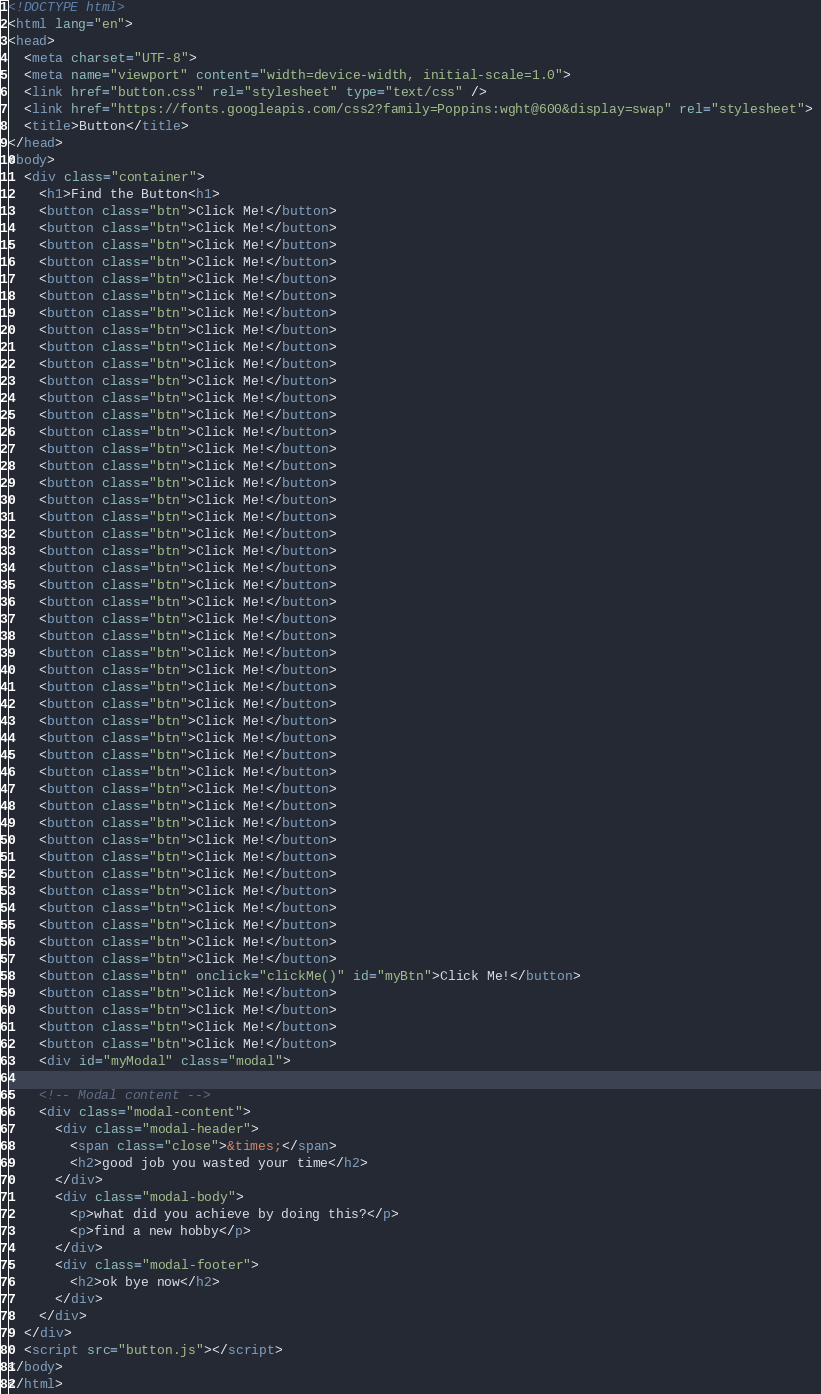Convert code to text. <code><loc_0><loc_0><loc_500><loc_500><_HTML_><!DOCTYPE html>
<html lang="en">
<head>
  <meta charset="UTF-8">
  <meta name="viewport" content="width=device-width, initial-scale=1.0">
  <link href="button.css" rel="stylesheet" type="text/css" />
  <link href="https://fonts.googleapis.com/css2?family=Poppins:wght@600&display=swap" rel="stylesheet"> 
  <title>Button</title>
</head>
<body>
  <div class="container">
    <h1>Find the Button<h1>
    <button class="btn">Click Me!</button>
    <button class="btn">Click Me!</button>
    <button class="btn">Click Me!</button>
    <button class="btn">Click Me!</button>
    <button class="btn">Click Me!</button>
    <button class="btn">Click Me!</button>
    <button class="btn">Click Me!</button>
    <button class="btn">Click Me!</button>
    <button class="btn">Click Me!</button>
    <button class="btn">Click Me!</button>
    <button class="btn">Click Me!</button>
    <button class="btn">Click Me!</button>
    <button class="btn">Click Me!</button>
    <button class="btn">Click Me!</button>
    <button class="btn">Click Me!</button>
    <button class="btn">Click Me!</button>
    <button class="btn">Click Me!</button>
    <button class="btn">Click Me!</button>
    <button class="btn">Click Me!</button>
    <button class="btn">Click Me!</button>
    <button class="btn">Click Me!</button>
    <button class="btn">Click Me!</button>
    <button class="btn">Click Me!</button>
    <button class="btn">Click Me!</button>
    <button class="btn">Click Me!</button>
    <button class="btn">Click Me!</button>
    <button class="btn">Click Me!</button>
    <button class="btn">Click Me!</button>
    <button class="btn">Click Me!</button>
    <button class="btn">Click Me!</button>
    <button class="btn">Click Me!</button>
    <button class="btn">Click Me!</button>
    <button class="btn">Click Me!</button>
    <button class="btn">Click Me!</button>
    <button class="btn">Click Me!</button>
    <button class="btn">Click Me!</button>
    <button class="btn">Click Me!</button>
    <button class="btn">Click Me!</button>
    <button class="btn">Click Me!</button>
    <button class="btn">Click Me!</button>
    <button class="btn">Click Me!</button>
    <button class="btn">Click Me!</button>
    <button class="btn">Click Me!</button>
    <button class="btn">Click Me!</button>
    <button class="btn">Click Me!</button>
    <button class="btn" onclick="clickMe()" id="myBtn">Click Me!</button>
    <button class="btn">Click Me!</button>
    <button class="btn">Click Me!</button>
    <button class="btn">Click Me!</button>
    <button class="btn">Click Me!</button>
    <div id="myModal" class="modal">

    <!-- Modal content -->
    <div class="modal-content">
      <div class="modal-header">
        <span class="close">&times;</span>
        <h2>good job you wasted your time</h2>
      </div>
      <div class="modal-body">
        <p>what did you achieve by doing this?</p>
        <p>find a new hobby</p>
      </div>
      <div class="modal-footer">
        <h2>ok bye now</h2>
      </div>
    </div>
  </div>
  <script src="button.js"></script>
</body>
</html>
</code> 